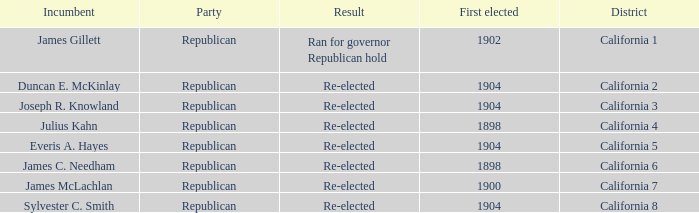Which District has a First Elected of 1904 and an Incumbent of Duncan E. Mckinlay? California 2. 